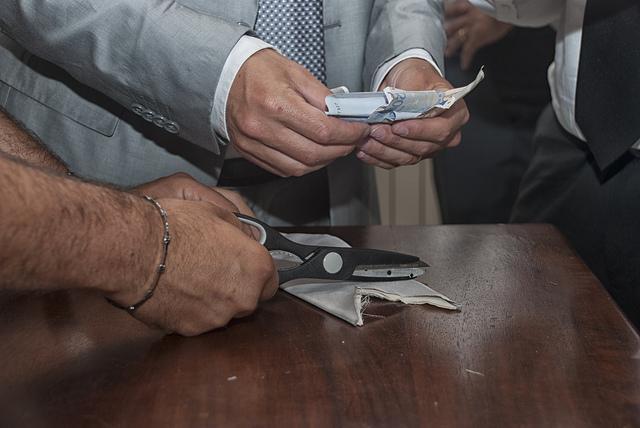How many ties are shown?
Give a very brief answer. 2. How many ties are visible?
Give a very brief answer. 3. How many people are there?
Give a very brief answer. 4. How many giraffes are sitting there?
Give a very brief answer. 0. 